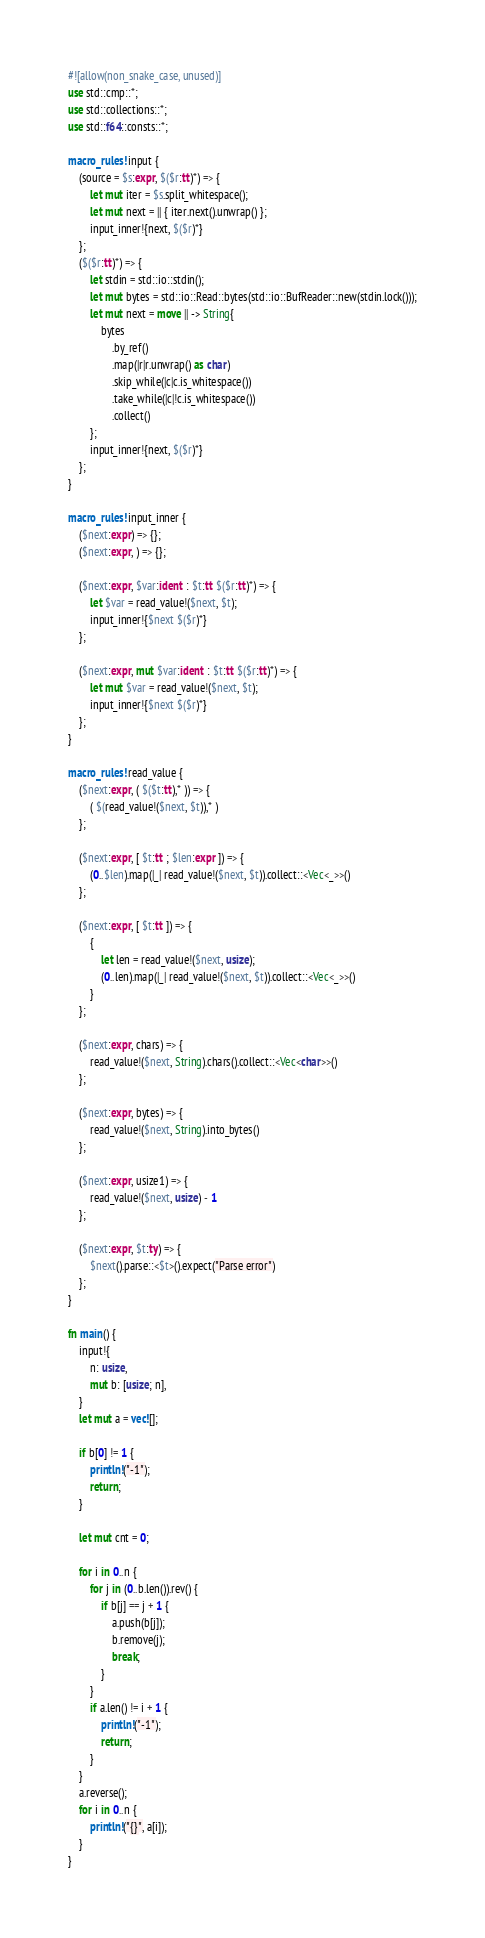<code> <loc_0><loc_0><loc_500><loc_500><_Rust_>#![allow(non_snake_case, unused)]
use std::cmp::*;
use std::collections::*;
use std::f64::consts::*;

macro_rules! input {
    (source = $s:expr, $($r:tt)*) => {
        let mut iter = $s.split_whitespace();
        let mut next = || { iter.next().unwrap() };
        input_inner!{next, $($r)*}
    };
    ($($r:tt)*) => {
        let stdin = std::io::stdin();
        let mut bytes = std::io::Read::bytes(std::io::BufReader::new(stdin.lock()));
        let mut next = move || -> String{
            bytes
                .by_ref()
                .map(|r|r.unwrap() as char)
                .skip_while(|c|c.is_whitespace())
                .take_while(|c|!c.is_whitespace())
                .collect()
        };
        input_inner!{next, $($r)*}
    };
}

macro_rules! input_inner {
    ($next:expr) => {};
    ($next:expr, ) => {};

    ($next:expr, $var:ident : $t:tt $($r:tt)*) => {
        let $var = read_value!($next, $t);
        input_inner!{$next $($r)*}
    };

    ($next:expr, mut $var:ident : $t:tt $($r:tt)*) => {
        let mut $var = read_value!($next, $t);
        input_inner!{$next $($r)*}
    };
}

macro_rules! read_value {
    ($next:expr, ( $($t:tt),* )) => {
        ( $(read_value!($next, $t)),* )
    };

    ($next:expr, [ $t:tt ; $len:expr ]) => {
        (0..$len).map(|_| read_value!($next, $t)).collect::<Vec<_>>()
    };

    ($next:expr, [ $t:tt ]) => {
        {
            let len = read_value!($next, usize);
            (0..len).map(|_| read_value!($next, $t)).collect::<Vec<_>>()
        }
    };

    ($next:expr, chars) => {
        read_value!($next, String).chars().collect::<Vec<char>>()
    };

    ($next:expr, bytes) => {
        read_value!($next, String).into_bytes()
    };

    ($next:expr, usize1) => {
        read_value!($next, usize) - 1
    };

    ($next:expr, $t:ty) => {
        $next().parse::<$t>().expect("Parse error")
    };
}

fn main() {
    input!{
        n: usize,
        mut b: [usize; n],
    }
    let mut a = vec![];

    if b[0] != 1 {
        println!("-1");
        return;
    }

    let mut cnt = 0;

    for i in 0..n {
        for j in (0..b.len()).rev() {
            if b[j] == j + 1 {
                a.push(b[j]);
                b.remove(j);
                break;
            }
        }
        if a.len() != i + 1 {
            println!("-1");
            return;
        }
    }
    a.reverse();
    for i in 0..n {
        println!("{}", a[i]);
    }
}
</code> 